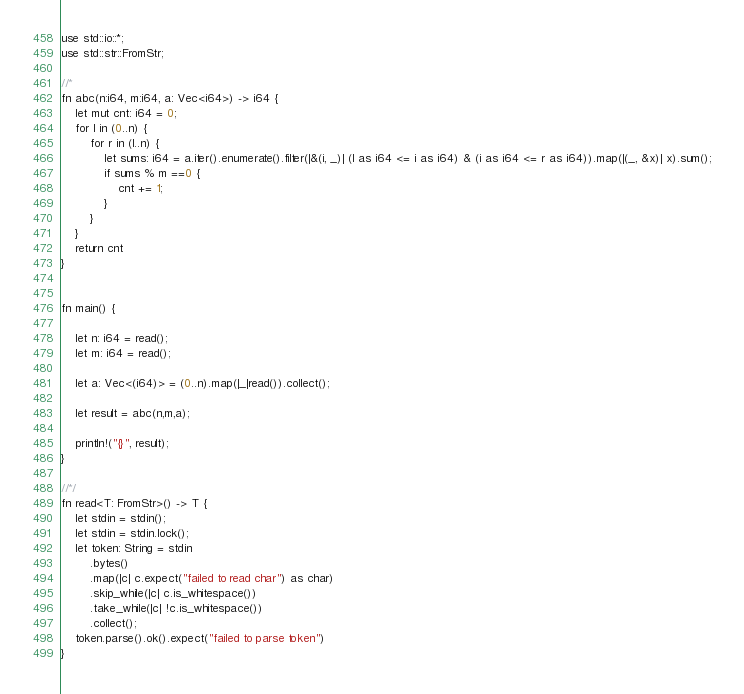Convert code to text. <code><loc_0><loc_0><loc_500><loc_500><_Rust_>use std::io::*;
use std::str::FromStr;

//*
fn abc(n:i64, m:i64, a: Vec<i64>) -> i64 {
    let mut cnt: i64 = 0;
    for l in (0..n) {
        for r in (l..n) {
            let sums: i64 = a.iter().enumerate().filter(|&(i, _)| (l as i64 <= i as i64) & (i as i64 <= r as i64)).map(|(_, &x)| x).sum();
            if sums % m ==0 {
                cnt += 1;
            }
        }
    }
    return cnt
}


fn main() {

    let n: i64 = read();
    let m: i64 = read();

    let a: Vec<(i64)> = (0..n).map(|_|read()).collect();

    let result = abc(n,m,a);
    
    println!("{}", result);
}

//*/
fn read<T: FromStr>() -> T {
    let stdin = stdin();
    let stdin = stdin.lock();
    let token: String = stdin
        .bytes()
        .map(|c| c.expect("failed to read char") as char) 
        .skip_while(|c| c.is_whitespace())
        .take_while(|c| !c.is_whitespace())
        .collect();
    token.parse().ok().expect("failed to parse token")
}</code> 